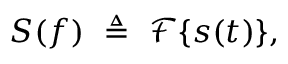Convert formula to latex. <formula><loc_0><loc_0><loc_500><loc_500>S ( f ) \ \triangle q \ { \mathcal { F } } \{ s ( t ) \} ,</formula> 